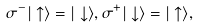<formula> <loc_0><loc_0><loc_500><loc_500>\sigma ^ { - } | \uparrow \rangle = | \downarrow \rangle , \sigma ^ { + } | \downarrow \rangle = | \uparrow \rangle ,</formula> 